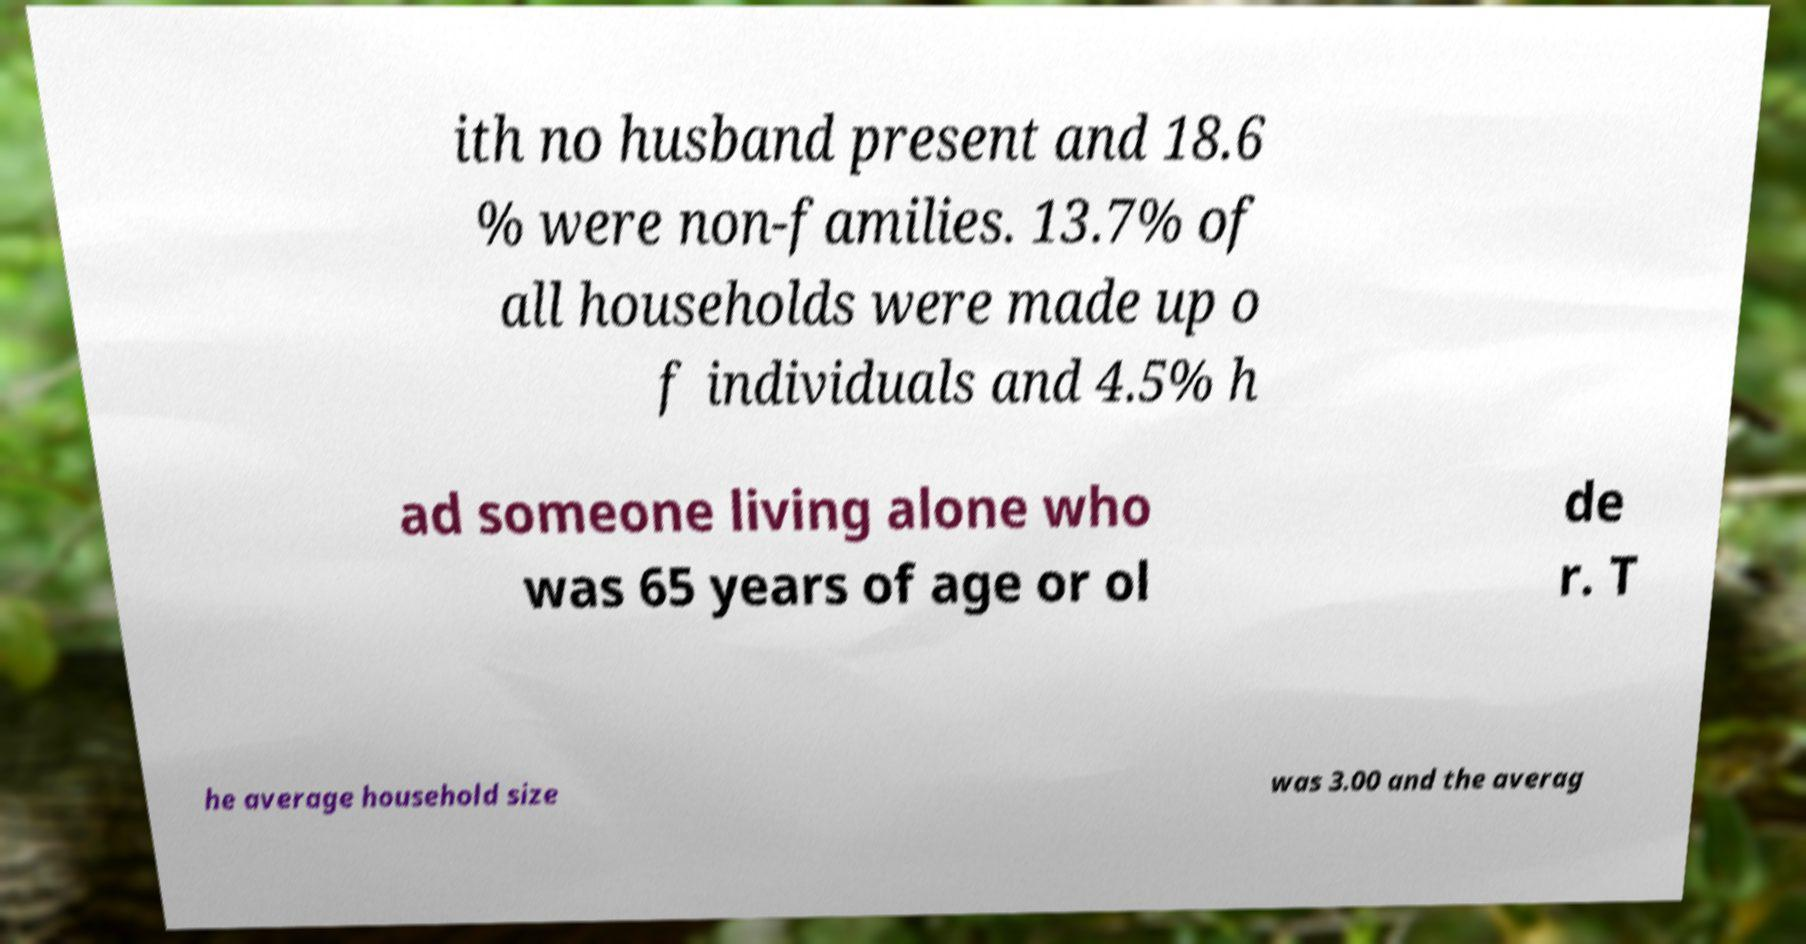I need the written content from this picture converted into text. Can you do that? ith no husband present and 18.6 % were non-families. 13.7% of all households were made up o f individuals and 4.5% h ad someone living alone who was 65 years of age or ol de r. T he average household size was 3.00 and the averag 